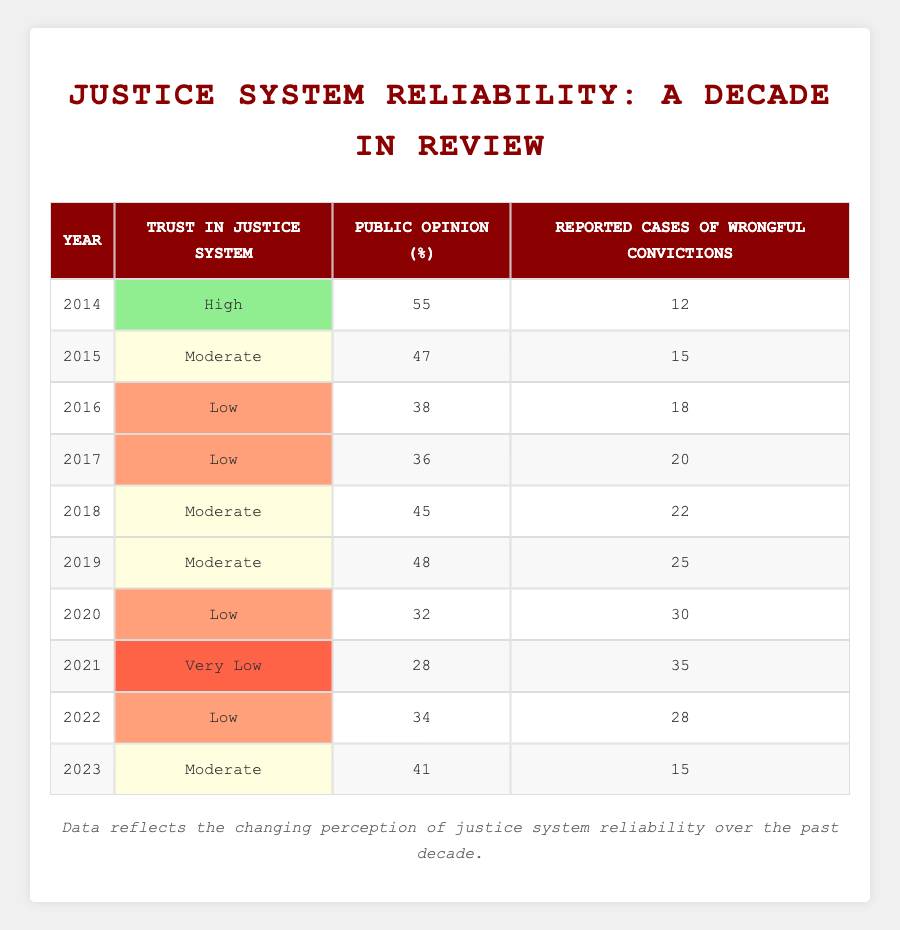What was the public opinion percentage in 2014? The table shows the public opinion percentage for each year, and for 2014 it is listed as 55.
Answer: 55 In which year did public opinion about the justice system reach its lowest percentage? Looking at the public opinion values across the years, the lowest percentage is found in 2021, which is 28.
Answer: 2021 How many reported cases of wrongful convictions were registered in 2016? Referring to the table, the reported cases of wrongful convictions in 2016 are listed as 18.
Answer: 18 What is the average public opinion percentage from 2014 to 2023? To calculate the average, sum the public opinion percentages from each year: (55 + 47 + 38 + 36 + 45 + 48 + 32 + 28 + 34 + 41) =  414. Divide by the number of years, which is 10: 414/10 = 41.4.
Answer: 41.4 Did the trust in the justice system improve from 2021 to 2022? In 2021, the trust was categorized as "Very Low," whereas in 2022 it changed to "Low." This indicates an improvement in the trust level.
Answer: Yes What was the trend in reported cases of wrongful convictions from 2014 to 2023? By examining the reported cases of wrongful convictions, they increased from 12 in 2014 to a peak of 35 in 2021, followed by a decrease to 15 in 2023. This pattern shows an initial rise, then a decline towards the end of the decade.
Answer: Increased then decreased What is the difference in public opinion percentage between 2015 and 2018? Public opinion in 2015 was 47 and in 2018 it was 45. To find the difference: 47 - 45 = 2.
Answer: 2 Which year had more reported cases of wrongful convictions: 2017 or 2020? In 2017, there were 20 cases reported, and in 2020, there were 30. Comparing these values, 30 (2020) is greater than 20 (2017).
Answer: 2020 How many years had a "Low" trust rating for the justice system? Analyzing the table, the years with a "Low" trust rating are 2016, 2017, 2020, and 2022, totaling four years.
Answer: 4 